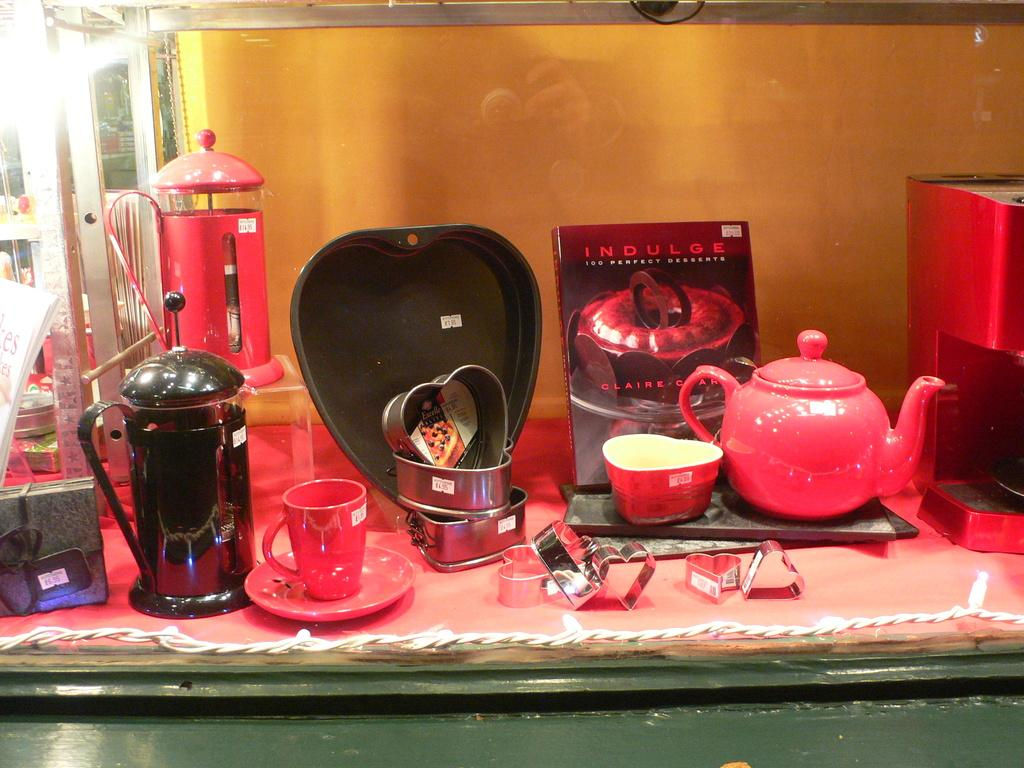<image>
Write a terse but informative summary of the picture. Next to some tea and cooking products likes a book titled Indulge 100 Perfect Desserts. 